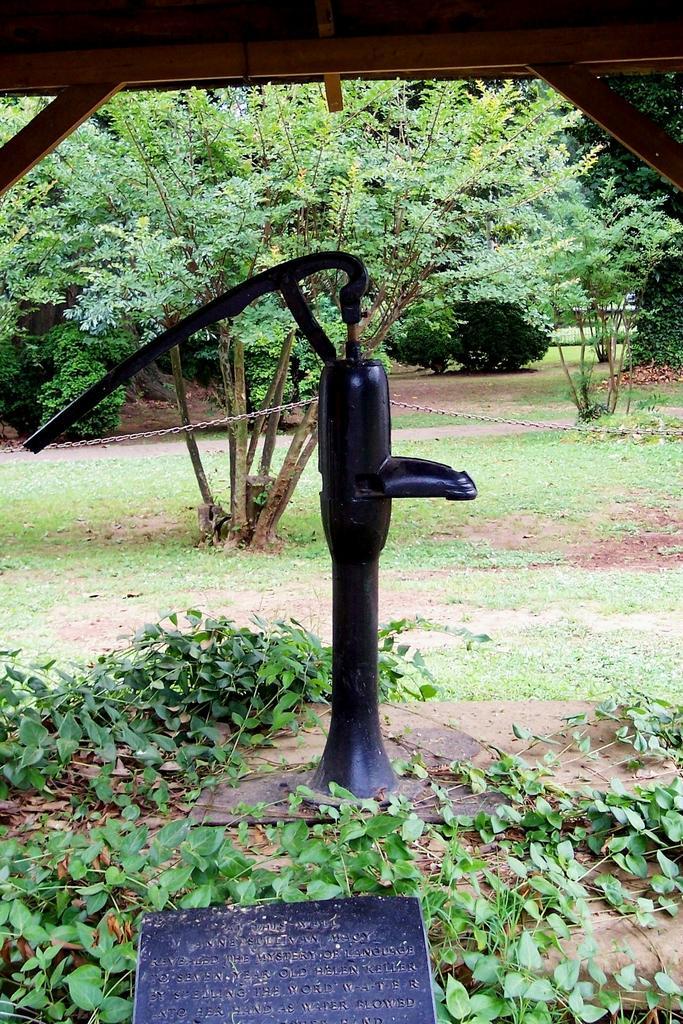Can you describe this image briefly? This picture is clicked outside. In the foreground we can see the leaves and a black color object lying on the ground. In the center there is a black color object seems to be a water hydrant. In the background we can see the trees, plants, and grass. At the top there is a tent. 